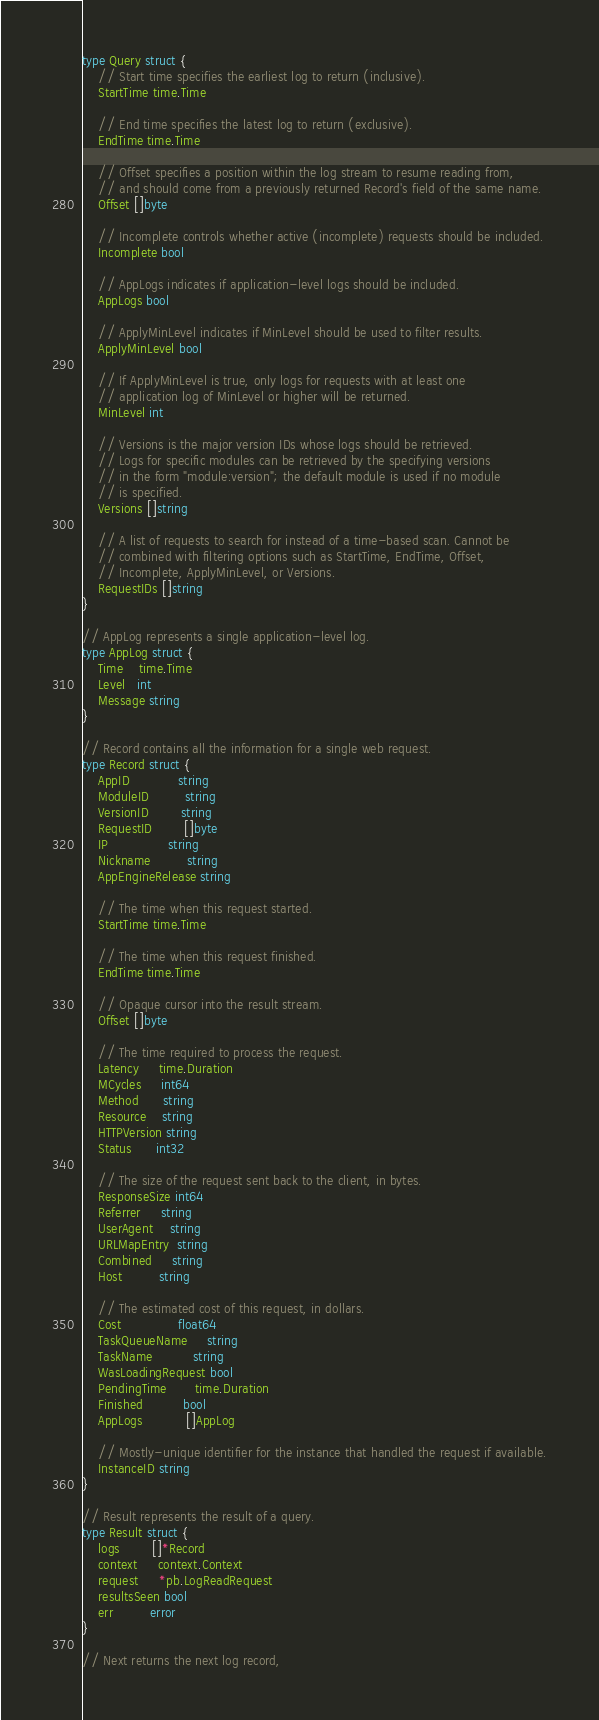Convert code to text. <code><loc_0><loc_0><loc_500><loc_500><_Go_>type Query struct {
	// Start time specifies the earliest log to return (inclusive).
	StartTime time.Time

	// End time specifies the latest log to return (exclusive).
	EndTime time.Time

	// Offset specifies a position within the log stream to resume reading from,
	// and should come from a previously returned Record's field of the same name.
	Offset []byte

	// Incomplete controls whether active (incomplete) requests should be included.
	Incomplete bool

	// AppLogs indicates if application-level logs should be included.
	AppLogs bool

	// ApplyMinLevel indicates if MinLevel should be used to filter results.
	ApplyMinLevel bool

	// If ApplyMinLevel is true, only logs for requests with at least one
	// application log of MinLevel or higher will be returned.
	MinLevel int

	// Versions is the major version IDs whose logs should be retrieved.
	// Logs for specific modules can be retrieved by the specifying versions
	// in the form "module:version"; the default module is used if no module
	// is specified.
	Versions []string

	// A list of requests to search for instead of a time-based scan. Cannot be
	// combined with filtering options such as StartTime, EndTime, Offset,
	// Incomplete, ApplyMinLevel, or Versions.
	RequestIDs []string
}

// AppLog represents a single application-level log.
type AppLog struct {
	Time    time.Time
	Level   int
	Message string
}

// Record contains all the information for a single web request.
type Record struct {
	AppID            string
	ModuleID         string
	VersionID        string
	RequestID        []byte
	IP               string
	Nickname         string
	AppEngineRelease string

	// The time when this request started.
	StartTime time.Time

	// The time when this request finished.
	EndTime time.Time

	// Opaque cursor into the result stream.
	Offset []byte

	// The time required to process the request.
	Latency     time.Duration
	MCycles     int64
	Method      string
	Resource    string
	HTTPVersion string
	Status      int32

	// The size of the request sent back to the client, in bytes.
	ResponseSize int64
	Referrer     string
	UserAgent    string
	URLMapEntry  string
	Combined     string
	Host         string

	// The estimated cost of this request, in dollars.
	Cost              float64
	TaskQueueName     string
	TaskName          string
	WasLoadingRequest bool
	PendingTime       time.Duration
	Finished          bool
	AppLogs           []AppLog

	// Mostly-unique identifier for the instance that handled the request if available.
	InstanceID string
}

// Result represents the result of a query.
type Result struct {
	logs        []*Record
	context     context.Context
	request     *pb.LogReadRequest
	resultsSeen bool
	err         error
}

// Next returns the next log record,</code> 